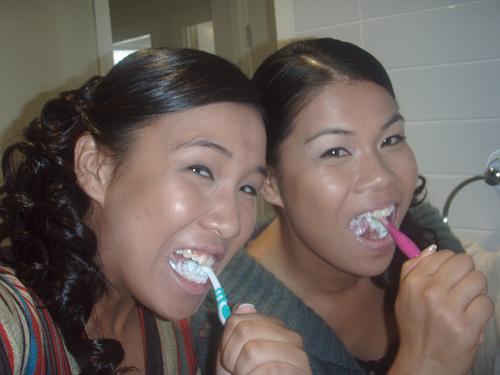What is the ethnicity of these women?
Keep it brief. Asian. What are the ladies doing?
Quick response, please. Brushing teeth. What color is the right toothbrush?
Answer briefly. Pink. 